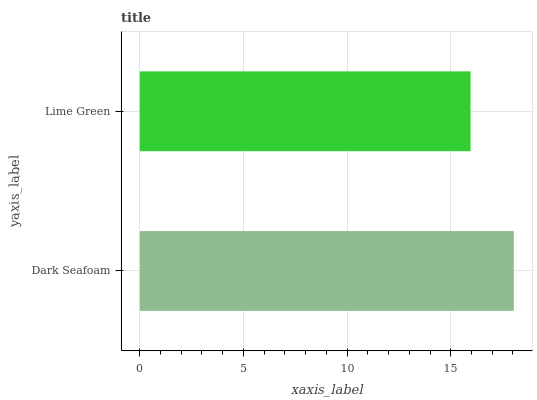Is Lime Green the minimum?
Answer yes or no. Yes. Is Dark Seafoam the maximum?
Answer yes or no. Yes. Is Lime Green the maximum?
Answer yes or no. No. Is Dark Seafoam greater than Lime Green?
Answer yes or no. Yes. Is Lime Green less than Dark Seafoam?
Answer yes or no. Yes. Is Lime Green greater than Dark Seafoam?
Answer yes or no. No. Is Dark Seafoam less than Lime Green?
Answer yes or no. No. Is Dark Seafoam the high median?
Answer yes or no. Yes. Is Lime Green the low median?
Answer yes or no. Yes. Is Lime Green the high median?
Answer yes or no. No. Is Dark Seafoam the low median?
Answer yes or no. No. 